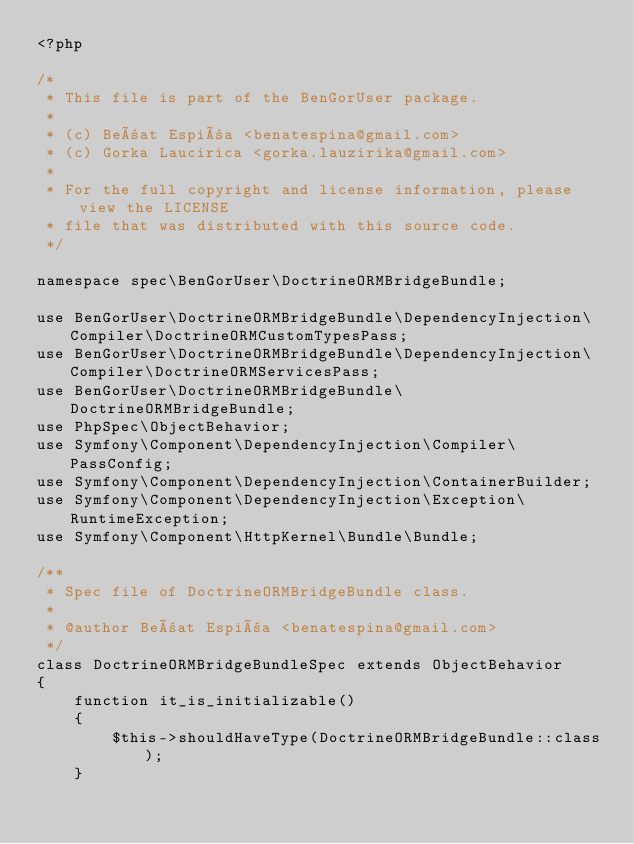Convert code to text. <code><loc_0><loc_0><loc_500><loc_500><_PHP_><?php

/*
 * This file is part of the BenGorUser package.
 *
 * (c) Beñat Espiña <benatespina@gmail.com>
 * (c) Gorka Laucirica <gorka.lauzirika@gmail.com>
 *
 * For the full copyright and license information, please view the LICENSE
 * file that was distributed with this source code.
 */

namespace spec\BenGorUser\DoctrineORMBridgeBundle;

use BenGorUser\DoctrineORMBridgeBundle\DependencyInjection\Compiler\DoctrineORMCustomTypesPass;
use BenGorUser\DoctrineORMBridgeBundle\DependencyInjection\Compiler\DoctrineORMServicesPass;
use BenGorUser\DoctrineORMBridgeBundle\DoctrineORMBridgeBundle;
use PhpSpec\ObjectBehavior;
use Symfony\Component\DependencyInjection\Compiler\PassConfig;
use Symfony\Component\DependencyInjection\ContainerBuilder;
use Symfony\Component\DependencyInjection\Exception\RuntimeException;
use Symfony\Component\HttpKernel\Bundle\Bundle;

/**
 * Spec file of DoctrineORMBridgeBundle class.
 *
 * @author Beñat Espiña <benatespina@gmail.com>
 */
class DoctrineORMBridgeBundleSpec extends ObjectBehavior
{
    function it_is_initializable()
    {
        $this->shouldHaveType(DoctrineORMBridgeBundle::class);
    }
</code> 